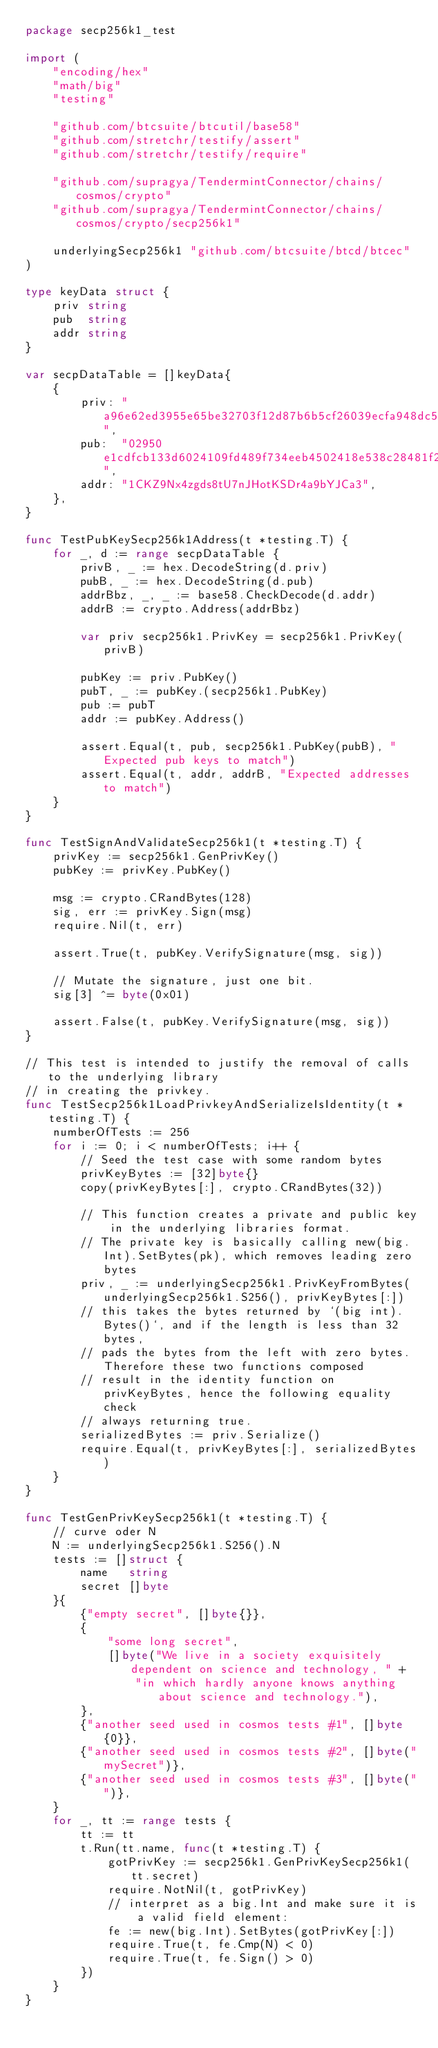Convert code to text. <code><loc_0><loc_0><loc_500><loc_500><_Go_>package secp256k1_test

import (
	"encoding/hex"
	"math/big"
	"testing"

	"github.com/btcsuite/btcutil/base58"
	"github.com/stretchr/testify/assert"
	"github.com/stretchr/testify/require"

	"github.com/supragya/TendermintConnector/chains/cosmos/crypto"
	"github.com/supragya/TendermintConnector/chains/cosmos/crypto/secp256k1"

	underlyingSecp256k1 "github.com/btcsuite/btcd/btcec"
)

type keyData struct {
	priv string
	pub  string
	addr string
}

var secpDataTable = []keyData{
	{
		priv: "a96e62ed3955e65be32703f12d87b6b5cf26039ecfa948dc5107a495418e5330",
		pub:  "02950e1cdfcb133d6024109fd489f734eeb4502418e538c28481f22bce276f248c",
		addr: "1CKZ9Nx4zgds8tU7nJHotKSDr4a9bYJCa3",
	},
}

func TestPubKeySecp256k1Address(t *testing.T) {
	for _, d := range secpDataTable {
		privB, _ := hex.DecodeString(d.priv)
		pubB, _ := hex.DecodeString(d.pub)
		addrBbz, _, _ := base58.CheckDecode(d.addr)
		addrB := crypto.Address(addrBbz)

		var priv secp256k1.PrivKey = secp256k1.PrivKey(privB)

		pubKey := priv.PubKey()
		pubT, _ := pubKey.(secp256k1.PubKey)
		pub := pubT
		addr := pubKey.Address()

		assert.Equal(t, pub, secp256k1.PubKey(pubB), "Expected pub keys to match")
		assert.Equal(t, addr, addrB, "Expected addresses to match")
	}
}

func TestSignAndValidateSecp256k1(t *testing.T) {
	privKey := secp256k1.GenPrivKey()
	pubKey := privKey.PubKey()

	msg := crypto.CRandBytes(128)
	sig, err := privKey.Sign(msg)
	require.Nil(t, err)

	assert.True(t, pubKey.VerifySignature(msg, sig))

	// Mutate the signature, just one bit.
	sig[3] ^= byte(0x01)

	assert.False(t, pubKey.VerifySignature(msg, sig))
}

// This test is intended to justify the removal of calls to the underlying library
// in creating the privkey.
func TestSecp256k1LoadPrivkeyAndSerializeIsIdentity(t *testing.T) {
	numberOfTests := 256
	for i := 0; i < numberOfTests; i++ {
		// Seed the test case with some random bytes
		privKeyBytes := [32]byte{}
		copy(privKeyBytes[:], crypto.CRandBytes(32))

		// This function creates a private and public key in the underlying libraries format.
		// The private key is basically calling new(big.Int).SetBytes(pk), which removes leading zero bytes
		priv, _ := underlyingSecp256k1.PrivKeyFromBytes(underlyingSecp256k1.S256(), privKeyBytes[:])
		// this takes the bytes returned by `(big int).Bytes()`, and if the length is less than 32 bytes,
		// pads the bytes from the left with zero bytes. Therefore these two functions composed
		// result in the identity function on privKeyBytes, hence the following equality check
		// always returning true.
		serializedBytes := priv.Serialize()
		require.Equal(t, privKeyBytes[:], serializedBytes)
	}
}

func TestGenPrivKeySecp256k1(t *testing.T) {
	// curve oder N
	N := underlyingSecp256k1.S256().N
	tests := []struct {
		name   string
		secret []byte
	}{
		{"empty secret", []byte{}},
		{
			"some long secret",
			[]byte("We live in a society exquisitely dependent on science and technology, " +
				"in which hardly anyone knows anything about science and technology."),
		},
		{"another seed used in cosmos tests #1", []byte{0}},
		{"another seed used in cosmos tests #2", []byte("mySecret")},
		{"another seed used in cosmos tests #3", []byte("")},
	}
	for _, tt := range tests {
		tt := tt
		t.Run(tt.name, func(t *testing.T) {
			gotPrivKey := secp256k1.GenPrivKeySecp256k1(tt.secret)
			require.NotNil(t, gotPrivKey)
			// interpret as a big.Int and make sure it is a valid field element:
			fe := new(big.Int).SetBytes(gotPrivKey[:])
			require.True(t, fe.Cmp(N) < 0)
			require.True(t, fe.Sign() > 0)
		})
	}
}
</code> 